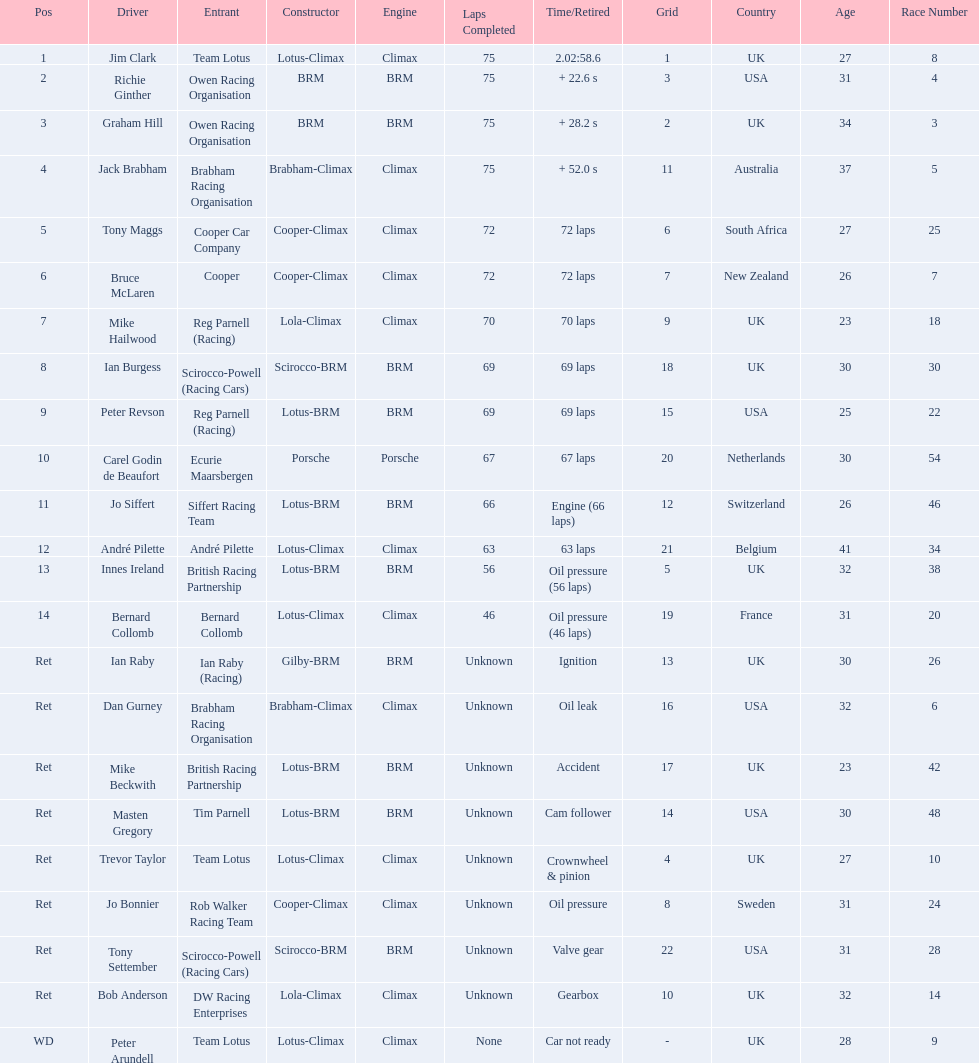What are the listed driver names? Jim Clark, Richie Ginther, Graham Hill, Jack Brabham, Tony Maggs, Bruce McLaren, Mike Hailwood, Ian Burgess, Peter Revson, Carel Godin de Beaufort, Jo Siffert, André Pilette, Innes Ireland, Bernard Collomb, Ian Raby, Dan Gurney, Mike Beckwith, Masten Gregory, Trevor Taylor, Jo Bonnier, Tony Settember, Bob Anderson, Peter Arundell. Which are tony maggs and jo siffert? Tony Maggs, Jo Siffert. What are their corresponding finishing places? 5, 11. Whose is better? Tony Maggs. 